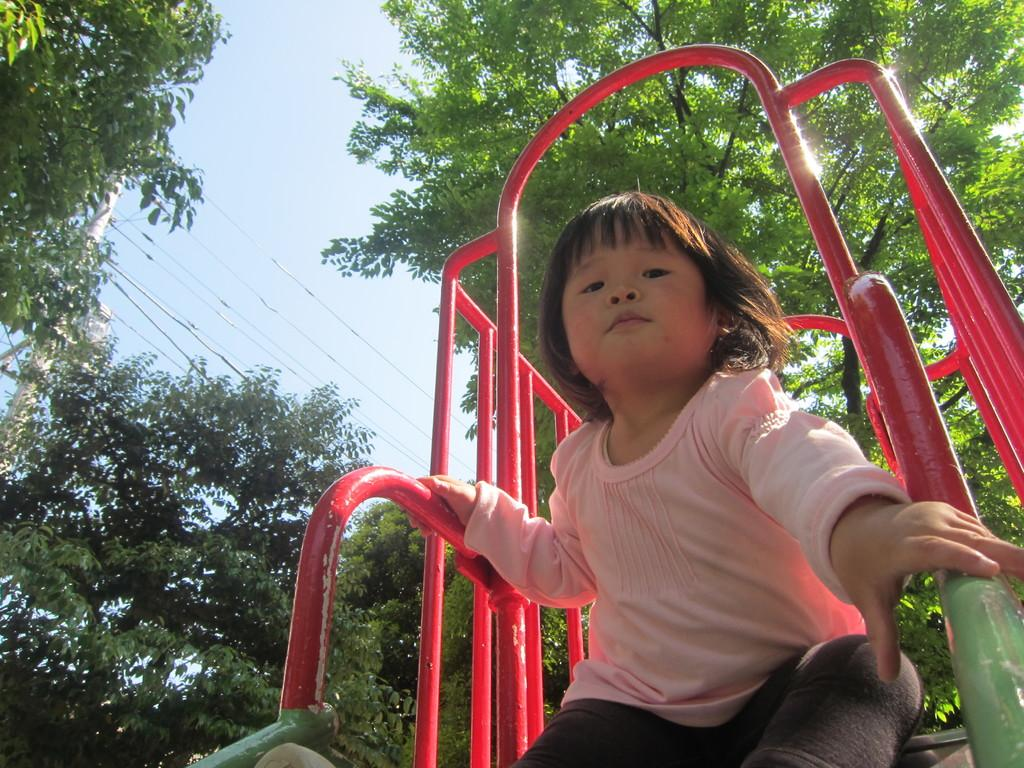What is the main subject of the image? There is a child on an amusement ride in the image. What can be seen in the background of the image? There are trees and the sky visible in the background of the image. What is located on the left side of the image? There is an electric pole with wires on the left side of the image. Can you tell me how many zebras are playing chess in the image? There are no zebras or chess games present in the image. What type of nerve is visible in the image? There is no nerve visible in the image; it features a child on an amusement ride, trees, and an electric pole with wires. 